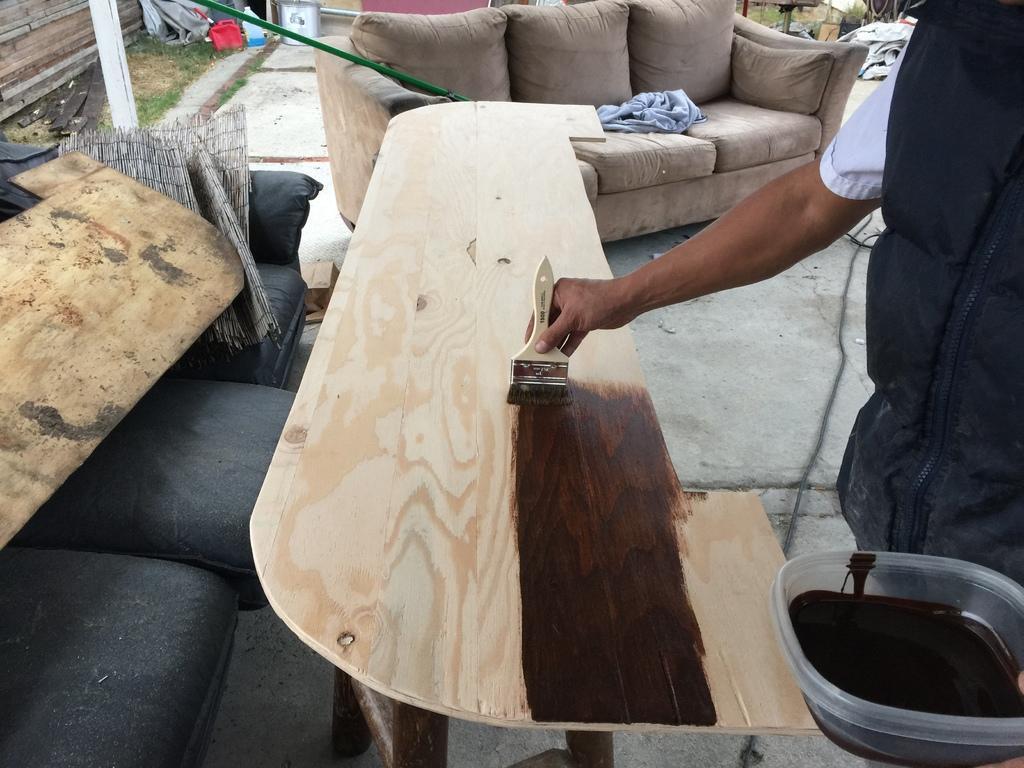Describe this image in one or two sentences. In this picture we can see a man is painting a wooden board with the help of brush and he is holding a bowl in his hand, in the background we can see a sofa and couple of cans. 